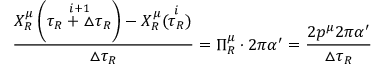<formula> <loc_0><loc_0><loc_500><loc_500>\frac { X _ { R } ^ { \mu } \left ( \stackrel { i + 1 } { \tau _ { R } + \triangle \tau _ { R } } \right ) - X _ { R } ^ { \mu } ( \stackrel { i } { \tau _ { R } } ) } { \triangle \tau _ { R } } = \Pi _ { R } ^ { \mu } \cdot 2 \pi \alpha ^ { \prime } = \frac { 2 p ^ { \mu } 2 \pi \alpha ^ { \prime } } { \triangle \tau _ { R } }</formula> 